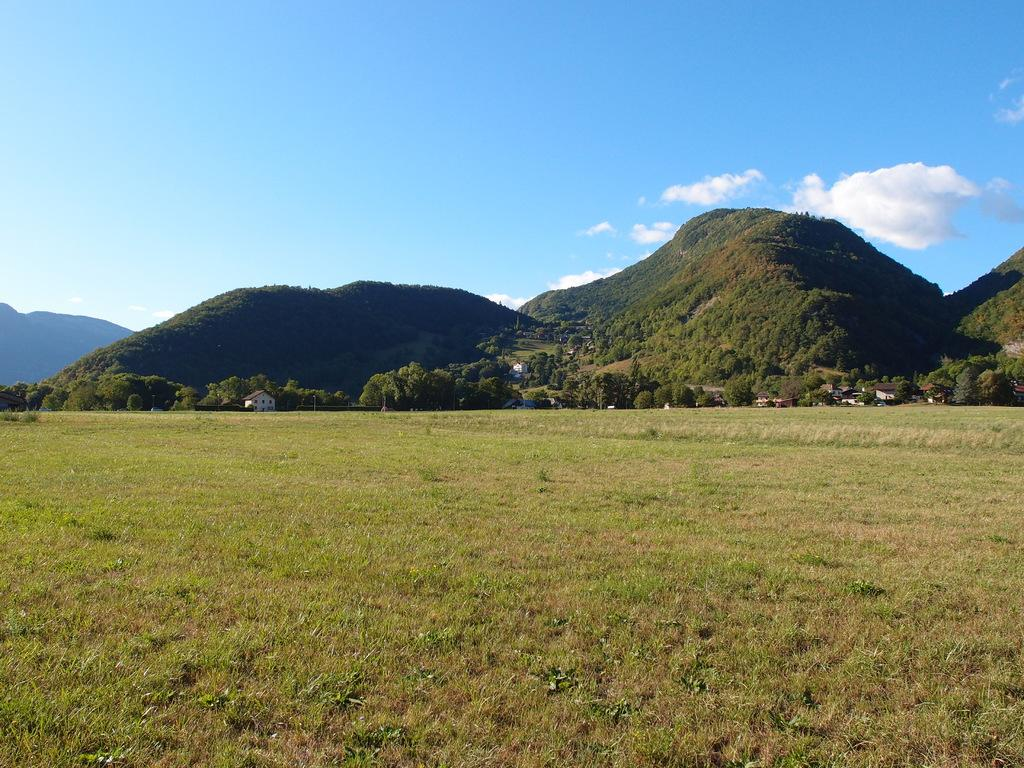What type of terrain is shown in the image? The image depicts a grassy land. What can be seen in the middle of the image? There are mountains in the middle of the image. What is present on the mountains? Trees and houses are visible on the mountains. What is visible at the top of the image? The sky is visible at the top of the image. What can be observed in the sky? Clouds are present in the sky. How many frogs are jumping on the grassy land in the image? There are no frogs present in the image; it depicts a grassy land with mountains, trees, houses, sky, and clouds. 